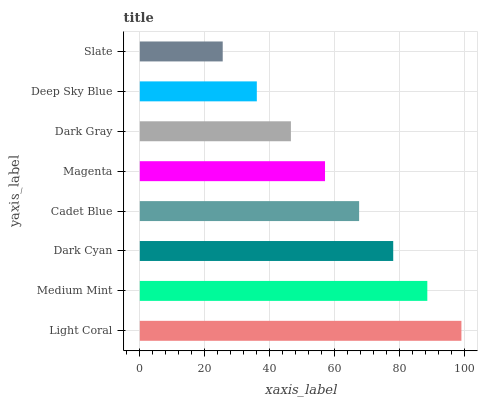Is Slate the minimum?
Answer yes or no. Yes. Is Light Coral the maximum?
Answer yes or no. Yes. Is Medium Mint the minimum?
Answer yes or no. No. Is Medium Mint the maximum?
Answer yes or no. No. Is Light Coral greater than Medium Mint?
Answer yes or no. Yes. Is Medium Mint less than Light Coral?
Answer yes or no. Yes. Is Medium Mint greater than Light Coral?
Answer yes or no. No. Is Light Coral less than Medium Mint?
Answer yes or no. No. Is Cadet Blue the high median?
Answer yes or no. Yes. Is Magenta the low median?
Answer yes or no. Yes. Is Deep Sky Blue the high median?
Answer yes or no. No. Is Slate the low median?
Answer yes or no. No. 